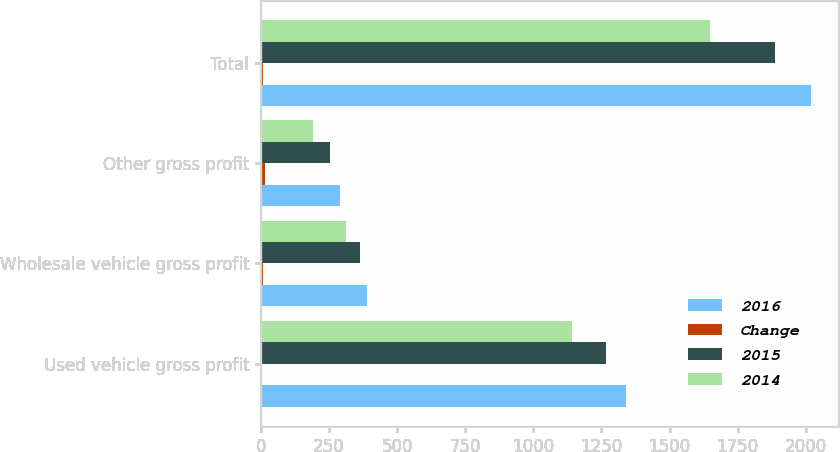<chart> <loc_0><loc_0><loc_500><loc_500><stacked_bar_chart><ecel><fcel>Used vehicle gross profit<fcel>Wholesale vehicle gross profit<fcel>Other gross profit<fcel>Total<nl><fcel>2016<fcel>1338.6<fcel>388.1<fcel>292.1<fcel>2018.8<nl><fcel>Change<fcel>5.5<fcel>6.4<fcel>14.9<fcel>7<nl><fcel>2015<fcel>1268.5<fcel>364.9<fcel>254.1<fcel>1887.5<nl><fcel>2014<fcel>1143.9<fcel>313.9<fcel>190.9<fcel>1648.7<nl></chart> 